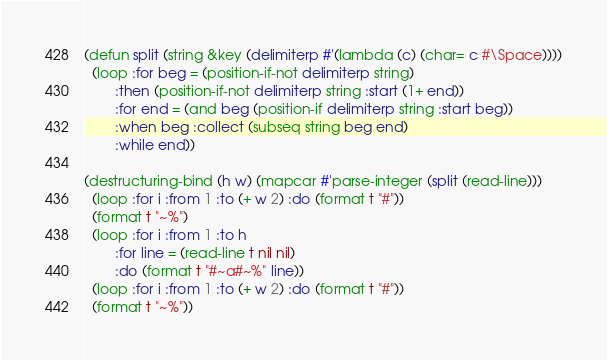<code> <loc_0><loc_0><loc_500><loc_500><_Lisp_>(defun split (string &key (delimiterp #'(lambda (c) (char= c #\Space))))
  (loop :for beg = (position-if-not delimiterp string)
        :then (position-if-not delimiterp string :start (1+ end))
        :for end = (and beg (position-if delimiterp string :start beg))
        :when beg :collect (subseq string beg end)
        :while end))

(destructuring-bind (h w) (mapcar #'parse-integer (split (read-line)))
  (loop :for i :from 1 :to (+ w 2) :do (format t "#"))
  (format t "~%")
  (loop :for i :from 1 :to h
        :for line = (read-line t nil nil)        
        :do (format t "#~a#~%" line))
  (loop :for i :from 1 :to (+ w 2) :do (format t "#"))
  (format t "~%"))
</code> 